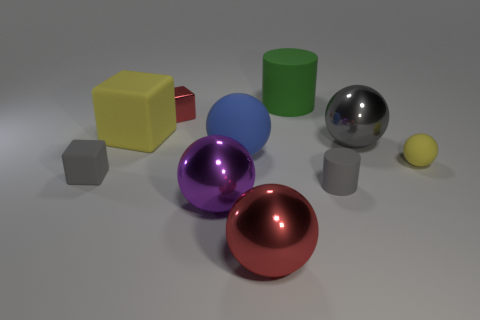Subtract 1 balls. How many balls are left? 4 Subtract all cyan spheres. Subtract all gray blocks. How many spheres are left? 5 Subtract all cubes. How many objects are left? 7 Subtract all large shiny objects. Subtract all purple cylinders. How many objects are left? 7 Add 8 tiny gray matte cubes. How many tiny gray matte cubes are left? 9 Add 1 big brown metal objects. How many big brown metal objects exist? 1 Subtract 0 cyan cylinders. How many objects are left? 10 